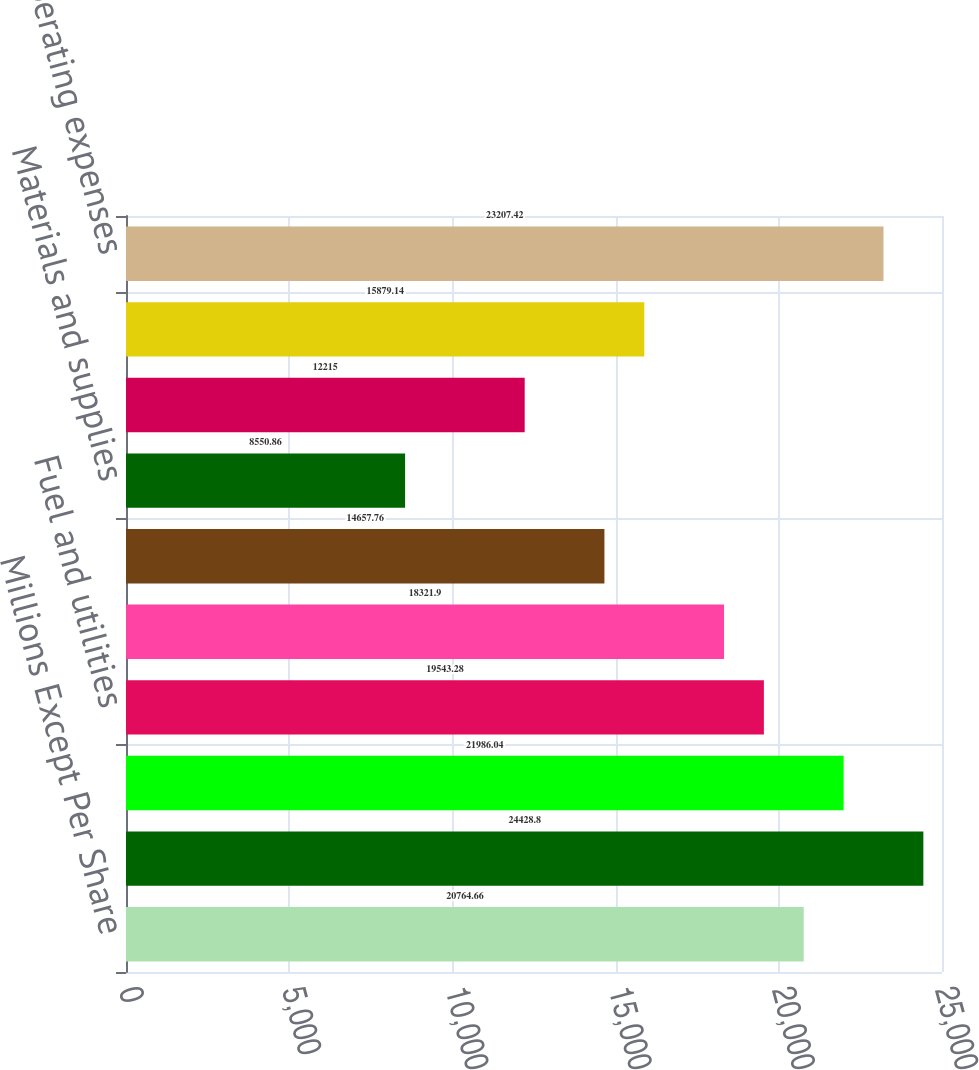<chart> <loc_0><loc_0><loc_500><loc_500><bar_chart><fcel>Millions Except Per Share<fcel>Operating revenue<fcel>Salaries wages and employee<fcel>Fuel and utilities<fcel>Equipment and other rents<fcel>Depreciation<fcel>Materials and supplies<fcel>Casualty costs<fcel>Purchased services and other<fcel>Total operating expenses<nl><fcel>20764.7<fcel>24428.8<fcel>21986<fcel>19543.3<fcel>18321.9<fcel>14657.8<fcel>8550.86<fcel>12215<fcel>15879.1<fcel>23207.4<nl></chart> 